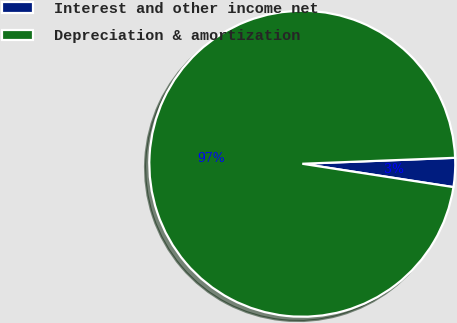<chart> <loc_0><loc_0><loc_500><loc_500><pie_chart><fcel>Interest and other income net<fcel>Depreciation & amortization<nl><fcel>3.06%<fcel>96.94%<nl></chart> 